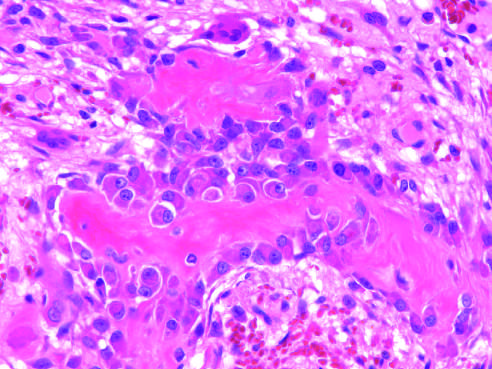do the surrounding spindle cells represent osteoprogenitor cells?
Answer the question using a single word or phrase. Yes 